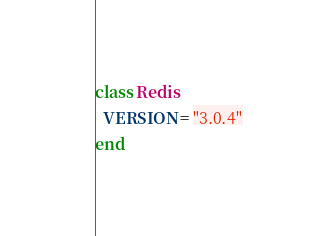Convert code to text. <code><loc_0><loc_0><loc_500><loc_500><_Ruby_>class Redis
  VERSION = "3.0.4"
end
</code> 